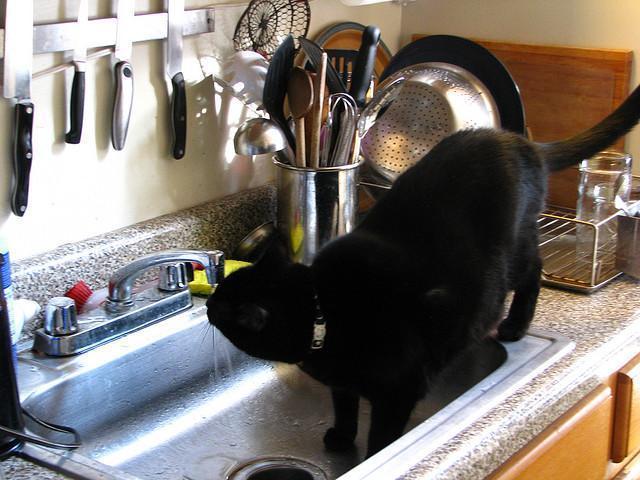How many knives are visible?
Give a very brief answer. 3. How many people are in the picture?
Give a very brief answer. 0. 